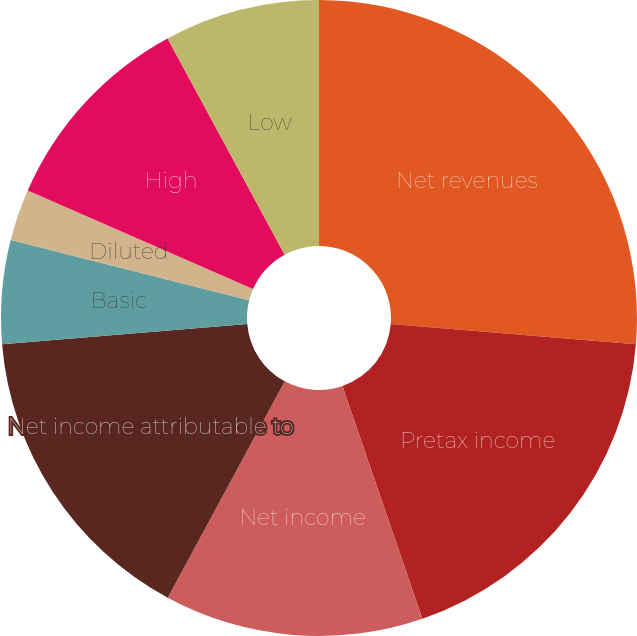Convert chart. <chart><loc_0><loc_0><loc_500><loc_500><pie_chart><fcel>Net revenues<fcel>Pretax income<fcel>Net income<fcel>Net income attributable to<fcel>Basic<fcel>Diluted<fcel>Cash dividends paid per common<fcel>High<fcel>Low<nl><fcel>26.31%<fcel>18.42%<fcel>13.16%<fcel>15.79%<fcel>5.26%<fcel>2.63%<fcel>0.0%<fcel>10.53%<fcel>7.9%<nl></chart> 